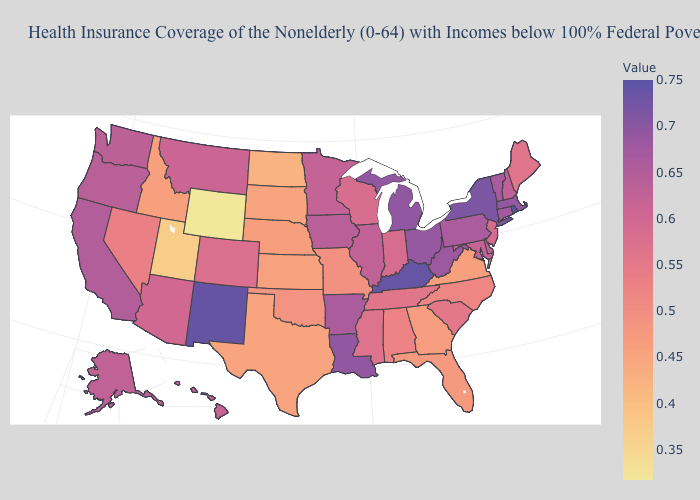Which states have the lowest value in the USA?
Quick response, please. Wyoming. Is the legend a continuous bar?
Answer briefly. Yes. Among the states that border Alabama , which have the lowest value?
Answer briefly. Georgia. Among the states that border Rhode Island , which have the lowest value?
Answer briefly. Connecticut. 